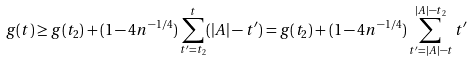<formula> <loc_0><loc_0><loc_500><loc_500>g ( t ) \geq g ( t _ { 2 } ) + ( 1 - 4 n ^ { - 1 / 4 } ) \sum _ { t ^ { \prime } = t _ { 2 } } ^ { t } ( | A | - t ^ { \prime } ) = g ( t _ { 2 } ) + ( 1 - 4 n ^ { - 1 / 4 } ) \sum _ { t ^ { \prime } = | A | - t } ^ { | A | - t _ { 2 } } t ^ { \prime }</formula> 